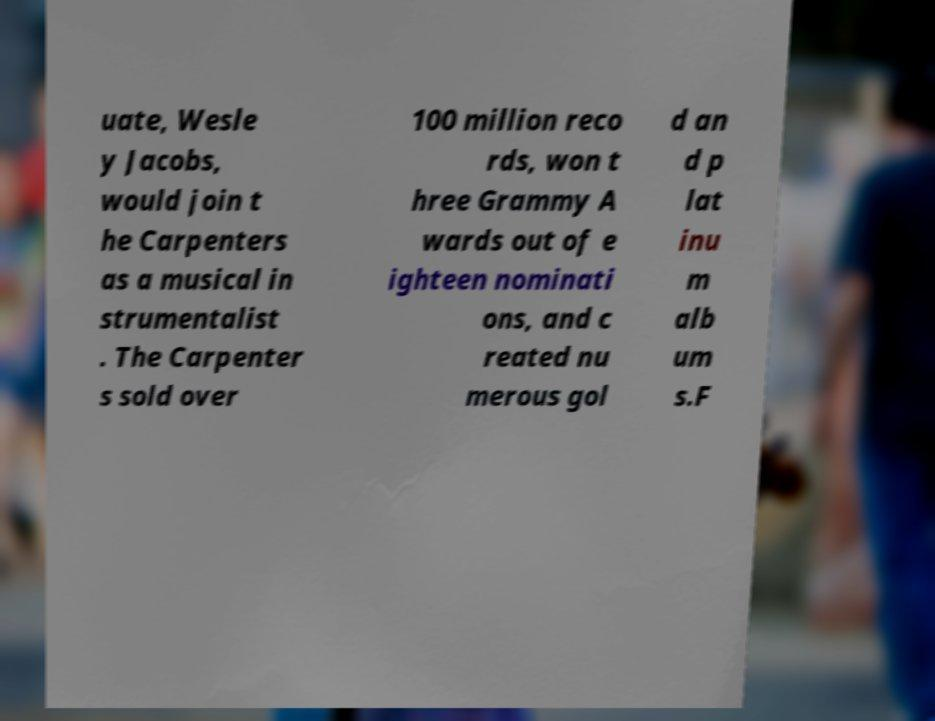Can you read and provide the text displayed in the image?This photo seems to have some interesting text. Can you extract and type it out for me? uate, Wesle y Jacobs, would join t he Carpenters as a musical in strumentalist . The Carpenter s sold over 100 million reco rds, won t hree Grammy A wards out of e ighteen nominati ons, and c reated nu merous gol d an d p lat inu m alb um s.F 